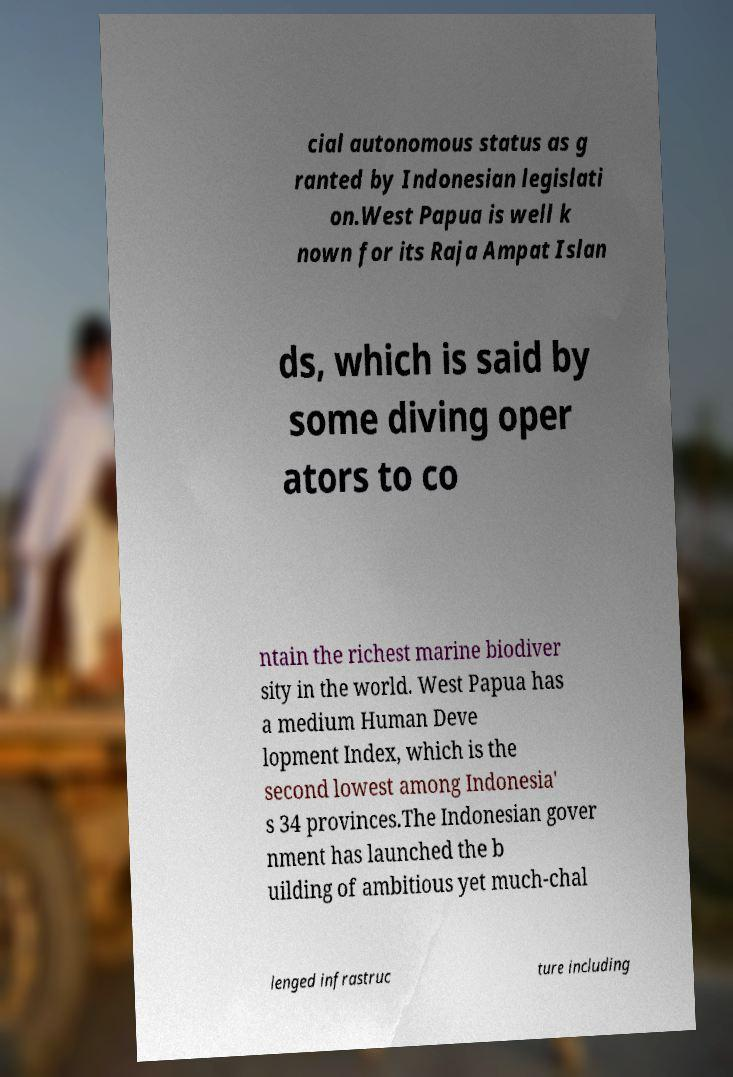Could you assist in decoding the text presented in this image and type it out clearly? cial autonomous status as g ranted by Indonesian legislati on.West Papua is well k nown for its Raja Ampat Islan ds, which is said by some diving oper ators to co ntain the richest marine biodiver sity in the world. West Papua has a medium Human Deve lopment Index, which is the second lowest among Indonesia' s 34 provinces.The Indonesian gover nment has launched the b uilding of ambitious yet much-chal lenged infrastruc ture including 